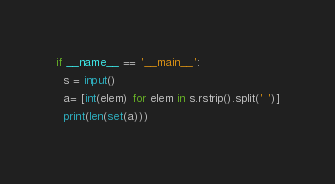<code> <loc_0><loc_0><loc_500><loc_500><_Python_>if __name__ == '__main__':
  s = input()
  a= [int(elem) for elem in s.rstrip().split(' ')]
  print(len(set(a)))</code> 